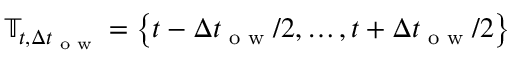Convert formula to latex. <formula><loc_0><loc_0><loc_500><loc_500>\mathbb { T } _ { t , \Delta t _ { o w } } = \left \{ t - \Delta t _ { o w } / 2 , \dots , t + \Delta t _ { o w } / 2 \right \}</formula> 